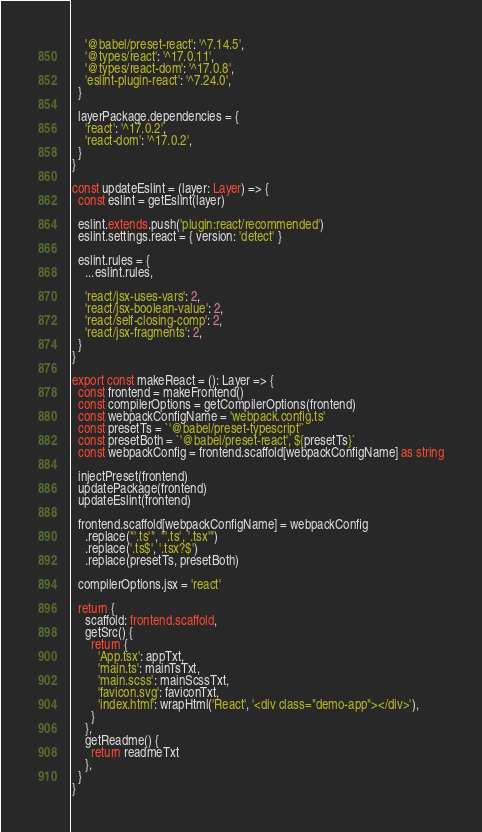Convert code to text. <code><loc_0><loc_0><loc_500><loc_500><_TypeScript_>
    '@babel/preset-react': '^7.14.5',
    '@types/react': '^17.0.11',
    '@types/react-dom': '^17.0.8',
    'eslint-plugin-react': '^7.24.0',
  }

  layerPackage.dependencies = {
    'react': '^17.0.2',
    'react-dom': '^17.0.2',
  }
}

const updateEslint = (layer: Layer) => {
  const eslint = getEslint(layer)

  eslint.extends.push('plugin:react/recommended')
  eslint.settings.react = { version: 'detect' }

  eslint.rules = {
    ...eslint.rules,

    'react/jsx-uses-vars': 2,
    'react/jsx-boolean-value': 2,
    'react/self-closing-comp': 2,
    'react/jsx-fragments': 2,
  }
}

export const makeReact = (): Layer => {
  const frontend = makeFrontend()
  const compilerOptions = getCompilerOptions(frontend)
  const webpackConfigName = 'webpack.config.ts'
  const presetTs = `'@babel/preset-typescript'`
  const presetBoth = `'@babel/preset-react', ${presetTs}`
  const webpackConfig = frontend.scaffold[webpackConfigName] as string

  injectPreset(frontend)
  updatePackage(frontend)
  updateEslint(frontend)

  frontend.scaffold[webpackConfigName] = webpackConfig
    .replace("'.ts'", "'.ts', '.tsx'")
    .replace('.ts$', '.tsx?$')
    .replace(presetTs, presetBoth)

  compilerOptions.jsx = 'react'

  return {
    scaffold: frontend.scaffold,
    getSrc() {
      return {
        'App.tsx': appTxt,
        'main.ts': mainTsTxt,
        'main.scss': mainScssTxt,
        'favicon.svg': faviconTxt,
        'index.html': wrapHtml('React', '<div class="demo-app"></div>'),
      }
    },
    getReadme() {
      return readmeTxt
    },
  }
}
</code> 